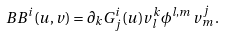<formula> <loc_0><loc_0><loc_500><loc_500>\ B B ^ { i } ( u , v ) = \partial _ { k } G ^ { i } _ { j } ( u ) v _ { l } ^ { k } \phi ^ { l , m } \, v _ { m } ^ { j } \, .</formula> 